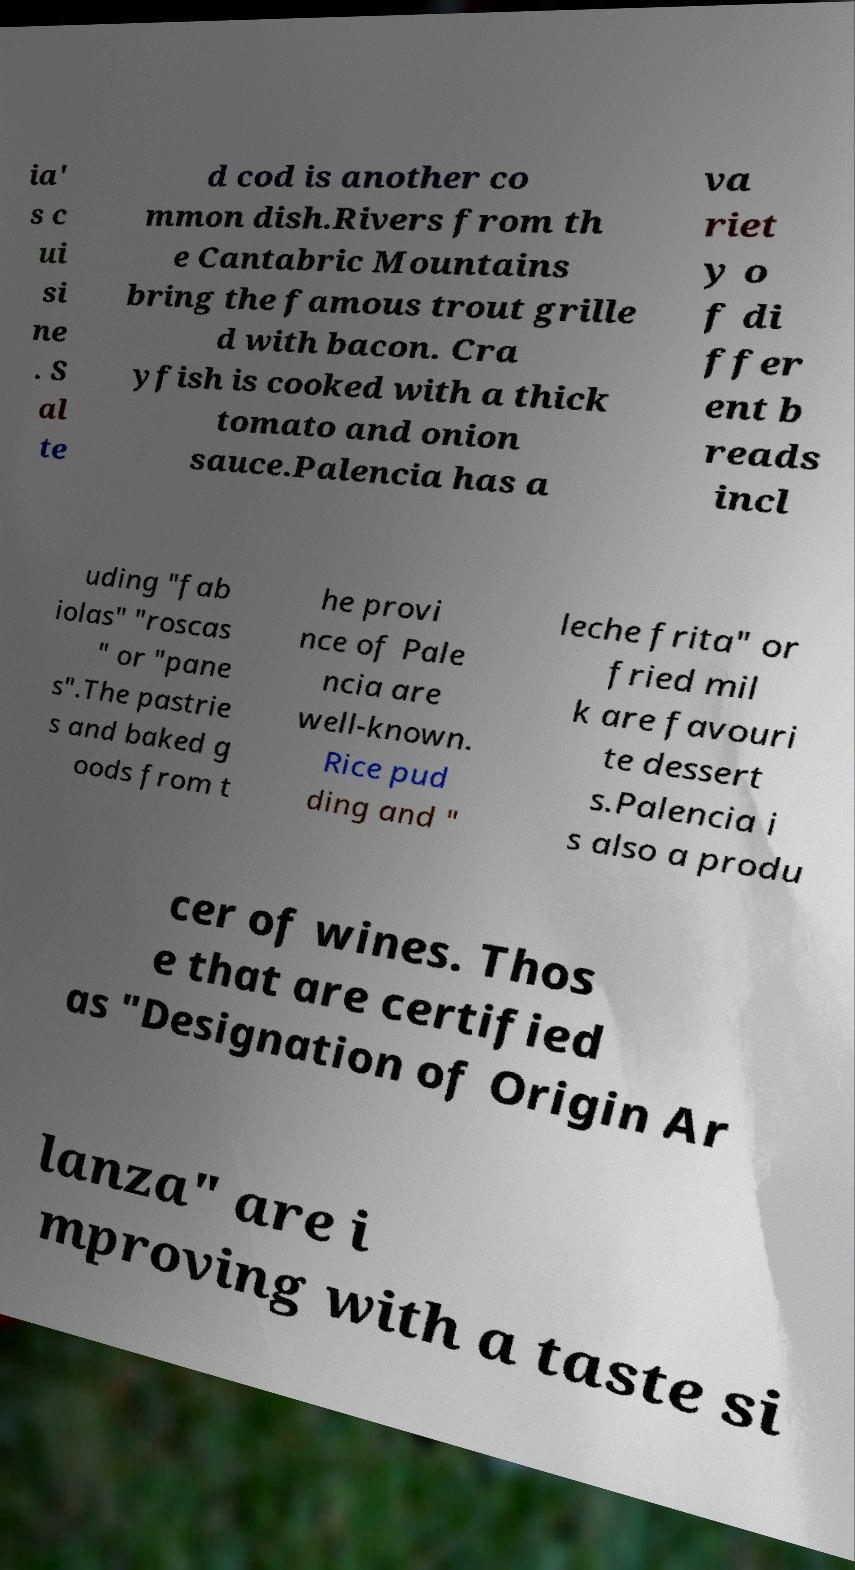Please identify and transcribe the text found in this image. ia' s c ui si ne . S al te d cod is another co mmon dish.Rivers from th e Cantabric Mountains bring the famous trout grille d with bacon. Cra yfish is cooked with a thick tomato and onion sauce.Palencia has a va riet y o f di ffer ent b reads incl uding "fab iolas" "roscas " or "pane s".The pastrie s and baked g oods from t he provi nce of Pale ncia are well-known. Rice pud ding and " leche frita" or fried mil k are favouri te dessert s.Palencia i s also a produ cer of wines. Thos e that are certified as "Designation of Origin Ar lanza" are i mproving with a taste si 